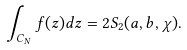<formula> <loc_0><loc_0><loc_500><loc_500>\int _ { C _ { N } } f ( z ) d z = 2 S _ { 2 } ( a , b , \chi ) .</formula> 